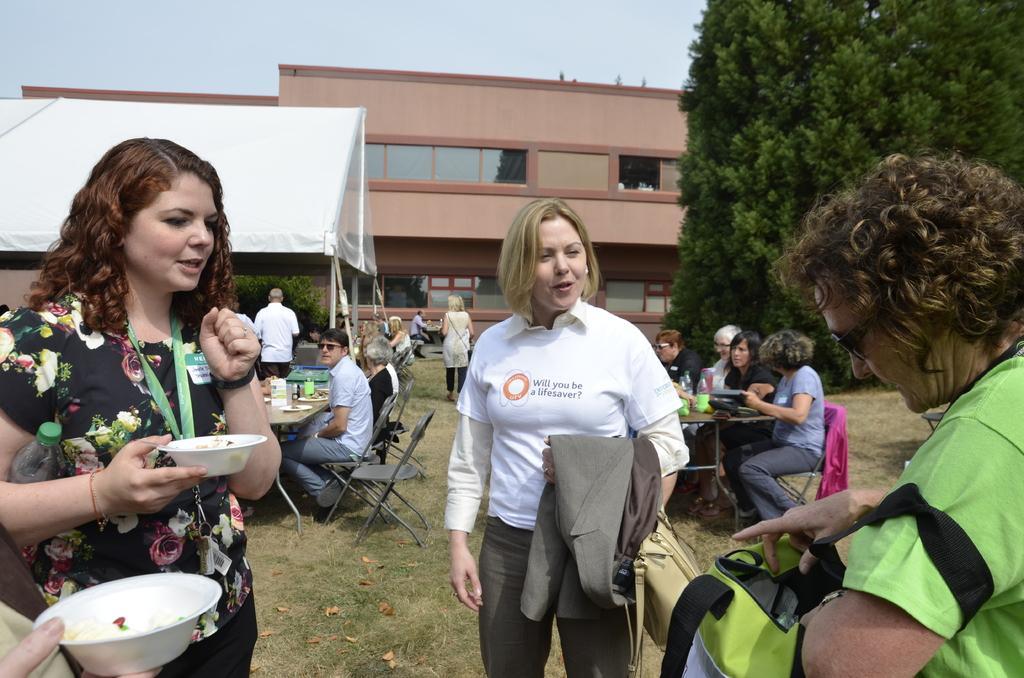In one or two sentences, can you explain what this image depicts? In the image we can see there are people standing, sitting and some of them are walking, they are wearing clothes. Here we can see a woman on the left side of the image is holding bowl in hand. On the right side, we can see a person carrying bag. There are many chairs and tables, and on the table there are many things. Here we can see pole tent, tree, grass, building and the sky. 